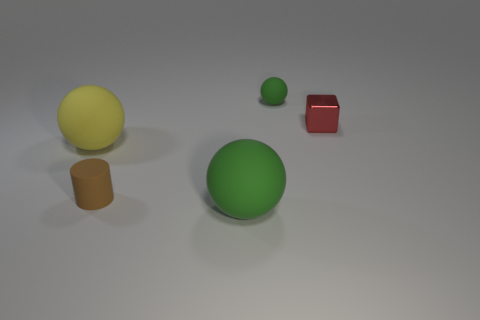Does the small ball have the same color as the large thing right of the matte cylinder?
Keep it short and to the point. Yes. There is a object that is the same color as the tiny sphere; what shape is it?
Provide a short and direct response. Sphere. Are there any green objects that have the same size as the yellow sphere?
Make the answer very short. Yes. What material is the other thing that is the same size as the yellow matte thing?
Provide a short and direct response. Rubber. There is a yellow sphere behind the cylinder; what is its size?
Keep it short and to the point. Large. What size is the yellow matte object?
Your answer should be very brief. Large. There is a cylinder; does it have the same size as the green sphere that is in front of the yellow thing?
Offer a very short reply. No. There is a object right of the green ball that is right of the big green rubber sphere; what color is it?
Keep it short and to the point. Red. Are there an equal number of large matte objects that are right of the small cylinder and tiny objects in front of the shiny thing?
Ensure brevity in your answer.  Yes. Is the material of the small thing that is behind the block the same as the brown thing?
Your answer should be compact. Yes. 